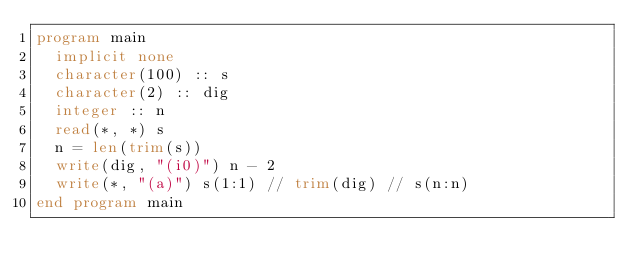<code> <loc_0><loc_0><loc_500><loc_500><_FORTRAN_>program main
  implicit none
  character(100) :: s
  character(2) :: dig
  integer :: n
  read(*, *) s
  n = len(trim(s))
  write(dig, "(i0)") n - 2
  write(*, "(a)") s(1:1) // trim(dig) // s(n:n)
end program main
</code> 